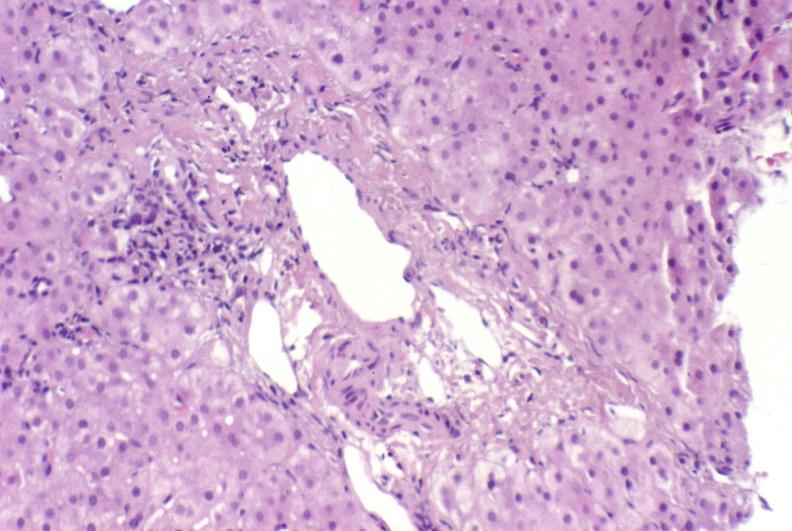does normal show ductopenia?
Answer the question using a single word or phrase. No 